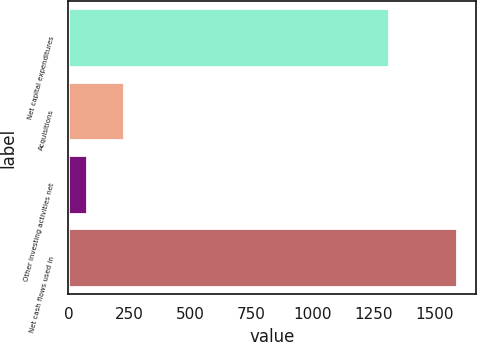<chart> <loc_0><loc_0><loc_500><loc_500><bar_chart><fcel>Net capital expenditures<fcel>Acquisitions<fcel>Other investing activities net<fcel>Net cash flows used in<nl><fcel>1311<fcel>226.5<fcel>75<fcel>1590<nl></chart> 